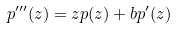<formula> <loc_0><loc_0><loc_500><loc_500>p ^ { \prime \prime \prime } ( z ) = z p ( z ) + b p ^ { \prime } ( z )</formula> 